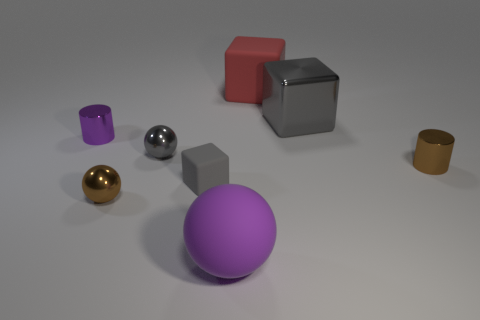Subtract all big purple rubber balls. How many balls are left? 2 Add 2 tiny balls. How many objects exist? 10 Subtract 1 cylinders. How many cylinders are left? 1 Subtract all gray blocks. How many blocks are left? 1 Subtract all blue cylinders. How many gray blocks are left? 2 Subtract 1 gray cubes. How many objects are left? 7 Subtract all cubes. How many objects are left? 5 Subtract all red cubes. Subtract all cyan cylinders. How many cubes are left? 2 Subtract all small matte objects. Subtract all large purple rubber objects. How many objects are left? 6 Add 4 cylinders. How many cylinders are left? 6 